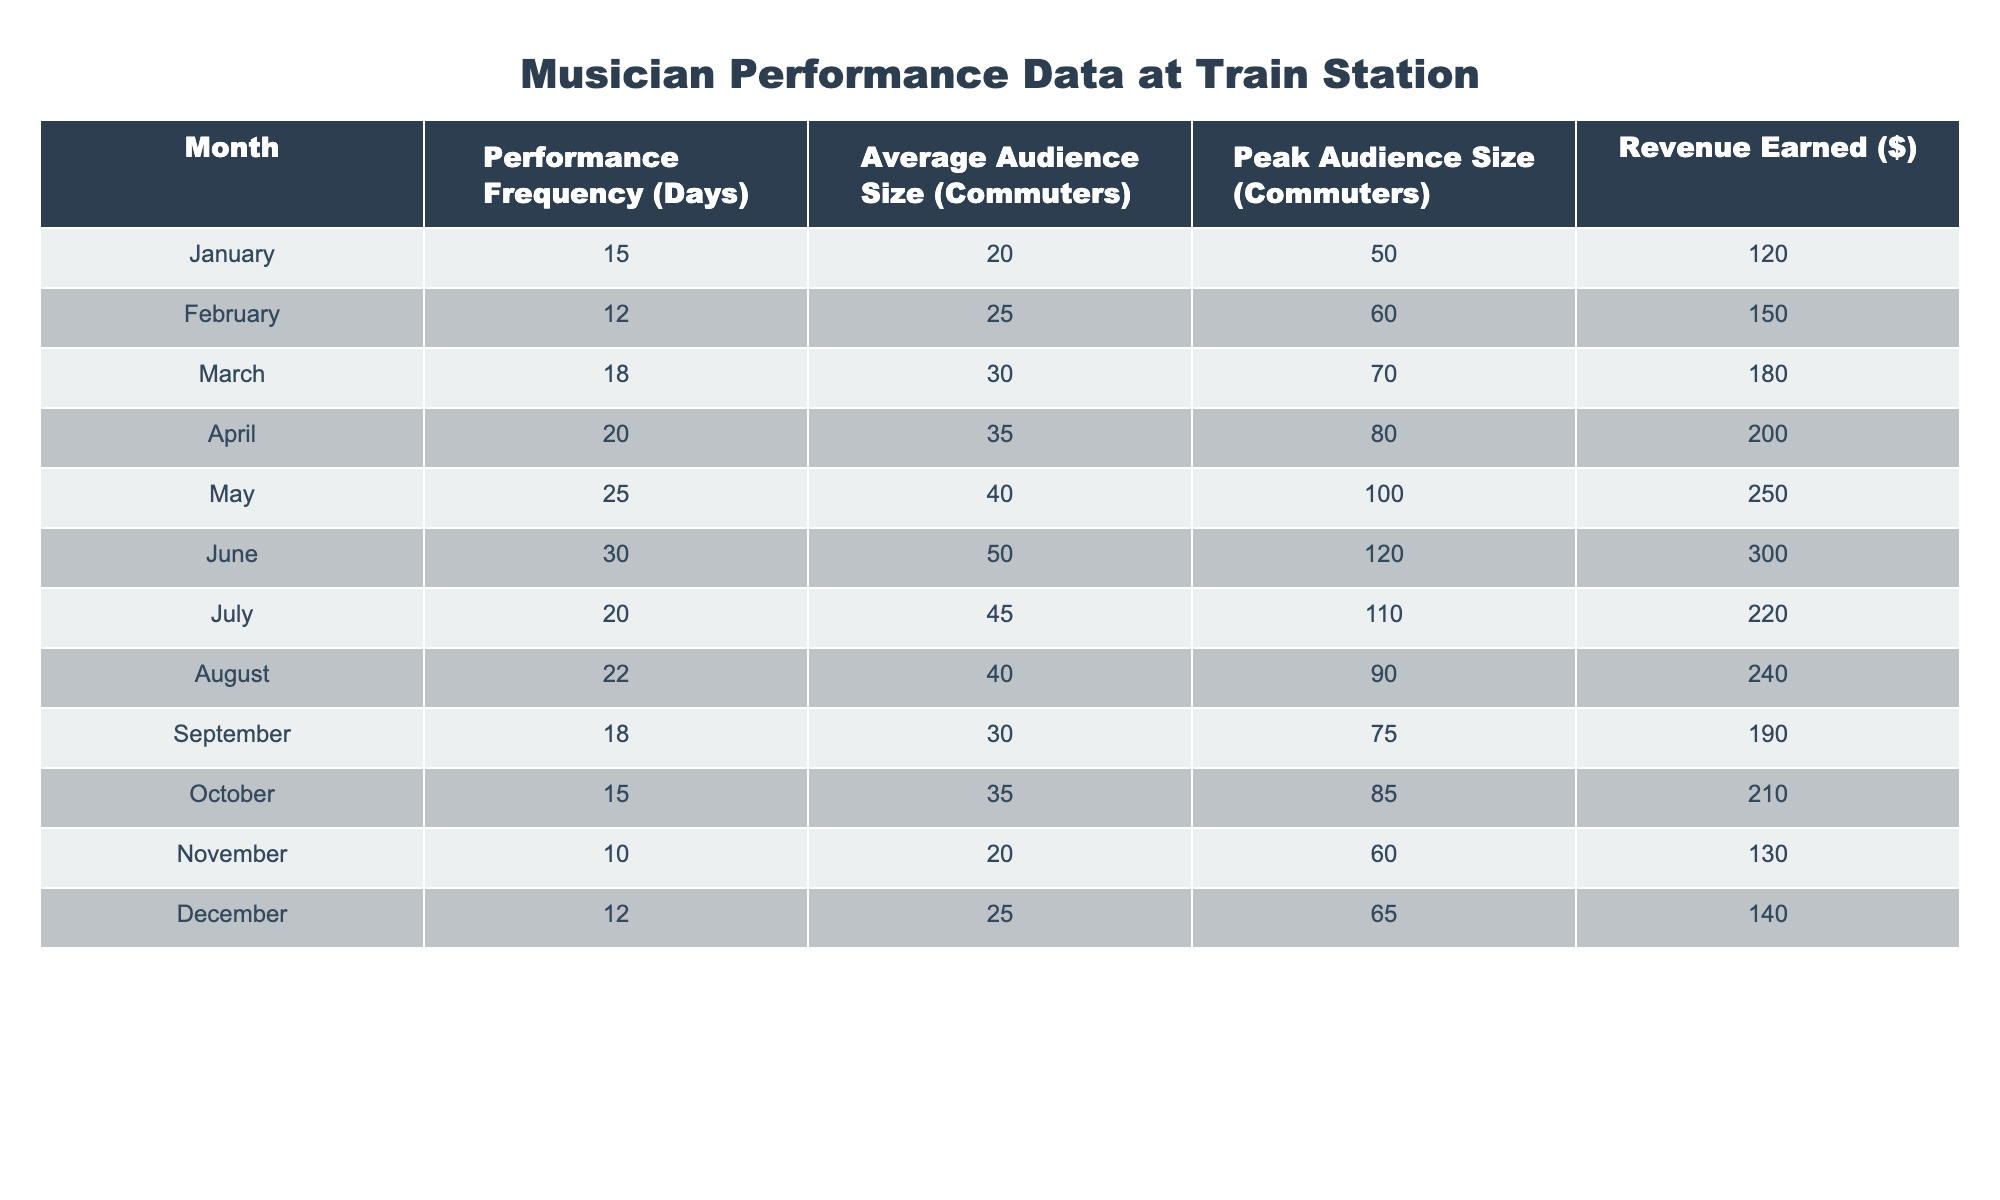What was the peak audience size in May? Referring to the table, in May, the peak audience size is listed as 100 commuters.
Answer: 100 What is the average audience size for the months where performances were held more than 20 days? To find this, we first identify the months with more than 20 performance days: May (40), June (50), July (45), and August (40). The average audience size for these months is (40 + 50 + 45 + 40) / 4 = 43.75, so it is approximately 44.
Answer: 44 Did the performance frequency decline in the last quarter (October, November, December) compared to the first quarter (January, February, March)? In the last quarter, the performance frequency is 15 (October) + 10 (November) + 12 (December) = 37 days; in the first quarter, it is 15 (January) + 12 (February) + 18 (March) = 45 days. Since 37 is less than 45, the performance frequency did decline.
Answer: Yes Which month had the highest revenue earned? According to the table, June shows the highest revenue earned at $300.
Answer: $300 What is the total revenue earned over the year? To calculate the total revenue, we sum up all the monthly revenues: 120 + 150 + 180 + 200 + 250 + 300 + 220 + 240 + 190 + 210 + 130 + 140 = 2190.
Answer: $2190 In which month was the average audience size the lowest and what was that size? Scanning through the table, November has the lowest average audience size of 20 commuters.
Answer: 20 How many more days did the musician perform in June than in November? The musician performed for 30 days in June and 10 days in November. The difference is 30 - 10 = 20 days.
Answer: 20 days Is the peak audience size in August greater than the average audience size in March? The peak audience size in August is 90, while the average audience size in March is 30. Since 90 is greater than 30, the statement is true.
Answer: Yes What was the percentage increase in average audience size from January to June? The average audience size increased from 20 (January) to 50 (June). The increase is (50 - 20) / 20 * 100 = 150%.
Answer: 150% 